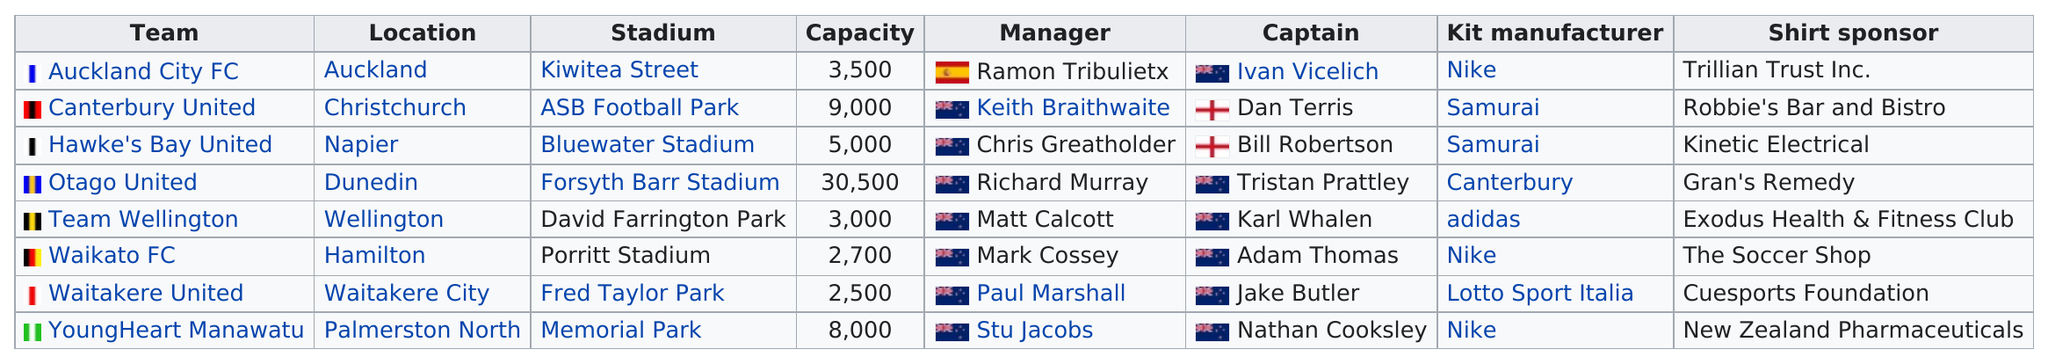Outline some significant characteristics in this image. There are five teams that share a common kit manufacturer. Specifically, among football venues that incorporate a person's first and last name into their name and are in last place in terms of seating capacity, there is one such venue known as Fred Taylor Park. Fred Taylor Park, which has the least capacity of all stadiums, is a testament to the importance of being able to accommodate a large number of people in a confined space. Five different kit manufacturers are involved in this project. Forsyth Barr Stadium is the only stadium in the world that can hold more than 10,000 people. 